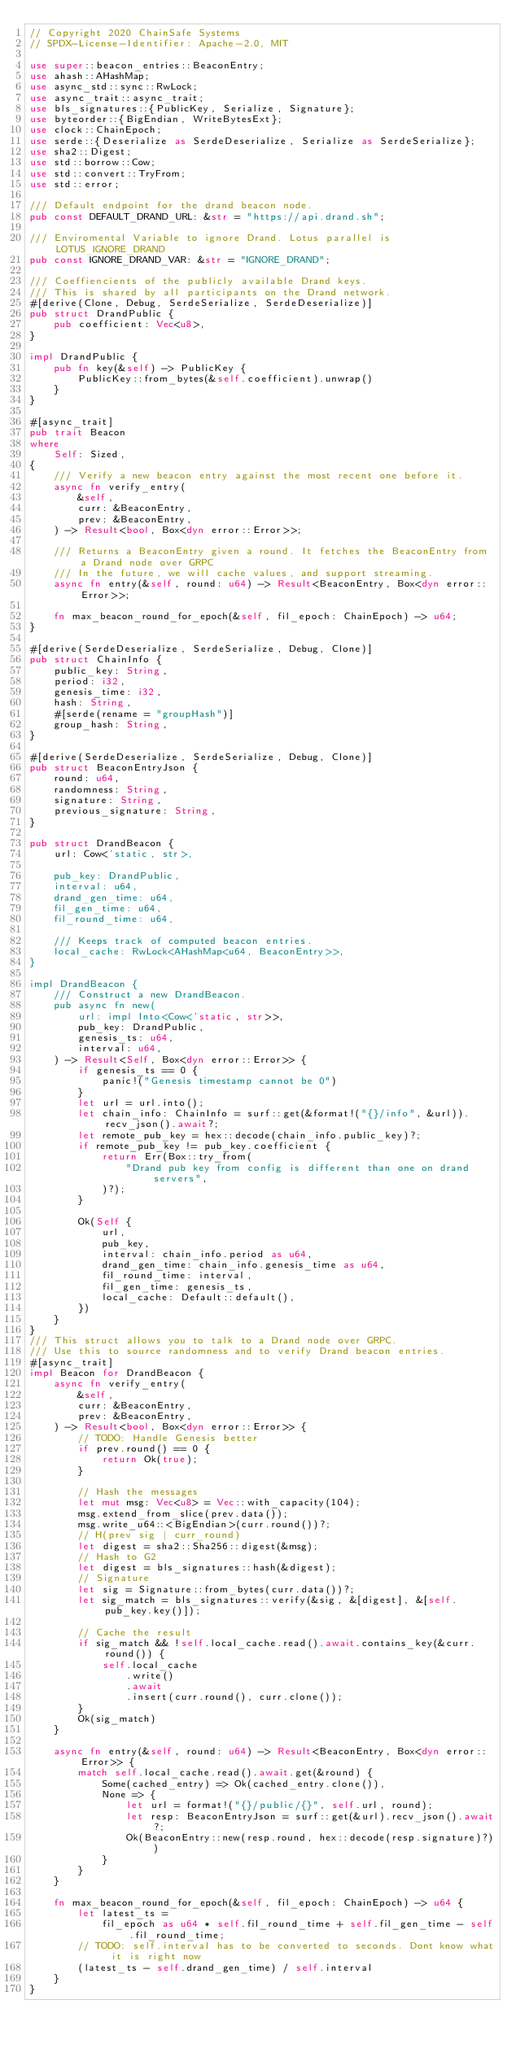<code> <loc_0><loc_0><loc_500><loc_500><_Rust_>// Copyright 2020 ChainSafe Systems
// SPDX-License-Identifier: Apache-2.0, MIT

use super::beacon_entries::BeaconEntry;
use ahash::AHashMap;
use async_std::sync::RwLock;
use async_trait::async_trait;
use bls_signatures::{PublicKey, Serialize, Signature};
use byteorder::{BigEndian, WriteBytesExt};
use clock::ChainEpoch;
use serde::{Deserialize as SerdeDeserialize, Serialize as SerdeSerialize};
use sha2::Digest;
use std::borrow::Cow;
use std::convert::TryFrom;
use std::error;

/// Default endpoint for the drand beacon node.
pub const DEFAULT_DRAND_URL: &str = "https://api.drand.sh";

/// Enviromental Variable to ignore Drand. Lotus parallel is LOTUS_IGNORE_DRAND
pub const IGNORE_DRAND_VAR: &str = "IGNORE_DRAND";

/// Coeffiencients of the publicly available Drand keys.
/// This is shared by all participants on the Drand network.
#[derive(Clone, Debug, SerdeSerialize, SerdeDeserialize)]
pub struct DrandPublic {
    pub coefficient: Vec<u8>,
}

impl DrandPublic {
    pub fn key(&self) -> PublicKey {
        PublicKey::from_bytes(&self.coefficient).unwrap()
    }
}

#[async_trait]
pub trait Beacon
where
    Self: Sized,
{
    /// Verify a new beacon entry against the most recent one before it.
    async fn verify_entry(
        &self,
        curr: &BeaconEntry,
        prev: &BeaconEntry,
    ) -> Result<bool, Box<dyn error::Error>>;

    /// Returns a BeaconEntry given a round. It fetches the BeaconEntry from a Drand node over GRPC
    /// In the future, we will cache values, and support streaming.
    async fn entry(&self, round: u64) -> Result<BeaconEntry, Box<dyn error::Error>>;

    fn max_beacon_round_for_epoch(&self, fil_epoch: ChainEpoch) -> u64;
}

#[derive(SerdeDeserialize, SerdeSerialize, Debug, Clone)]
pub struct ChainInfo {
    public_key: String,
    period: i32,
    genesis_time: i32,
    hash: String,
    #[serde(rename = "groupHash")]
    group_hash: String,
}

#[derive(SerdeDeserialize, SerdeSerialize, Debug, Clone)]
pub struct BeaconEntryJson {
    round: u64,
    randomness: String,
    signature: String,
    previous_signature: String,
}

pub struct DrandBeacon {
    url: Cow<'static, str>,

    pub_key: DrandPublic,
    interval: u64,
    drand_gen_time: u64,
    fil_gen_time: u64,
    fil_round_time: u64,

    /// Keeps track of computed beacon entries.
    local_cache: RwLock<AHashMap<u64, BeaconEntry>>,
}

impl DrandBeacon {
    /// Construct a new DrandBeacon.
    pub async fn new(
        url: impl Into<Cow<'static, str>>,
        pub_key: DrandPublic,
        genesis_ts: u64,
        interval: u64,
    ) -> Result<Self, Box<dyn error::Error>> {
        if genesis_ts == 0 {
            panic!("Genesis timestamp cannot be 0")
        }
        let url = url.into();
        let chain_info: ChainInfo = surf::get(&format!("{}/info", &url)).recv_json().await?;
        let remote_pub_key = hex::decode(chain_info.public_key)?;
        if remote_pub_key != pub_key.coefficient {
            return Err(Box::try_from(
                "Drand pub key from config is different than one on drand servers",
            )?);
        }

        Ok(Self {
            url,
            pub_key,
            interval: chain_info.period as u64,
            drand_gen_time: chain_info.genesis_time as u64,
            fil_round_time: interval,
            fil_gen_time: genesis_ts,
            local_cache: Default::default(),
        })
    }
}
/// This struct allows you to talk to a Drand node over GRPC.
/// Use this to source randomness and to verify Drand beacon entries.
#[async_trait]
impl Beacon for DrandBeacon {
    async fn verify_entry(
        &self,
        curr: &BeaconEntry,
        prev: &BeaconEntry,
    ) -> Result<bool, Box<dyn error::Error>> {
        // TODO: Handle Genesis better
        if prev.round() == 0 {
            return Ok(true);
        }

        // Hash the messages
        let mut msg: Vec<u8> = Vec::with_capacity(104);
        msg.extend_from_slice(prev.data());
        msg.write_u64::<BigEndian>(curr.round())?;
        // H(prev sig | curr_round)
        let digest = sha2::Sha256::digest(&msg);
        // Hash to G2
        let digest = bls_signatures::hash(&digest);
        // Signature
        let sig = Signature::from_bytes(curr.data())?;
        let sig_match = bls_signatures::verify(&sig, &[digest], &[self.pub_key.key()]);

        // Cache the result
        if sig_match && !self.local_cache.read().await.contains_key(&curr.round()) {
            self.local_cache
                .write()
                .await
                .insert(curr.round(), curr.clone());
        }
        Ok(sig_match)
    }

    async fn entry(&self, round: u64) -> Result<BeaconEntry, Box<dyn error::Error>> {
        match self.local_cache.read().await.get(&round) {
            Some(cached_entry) => Ok(cached_entry.clone()),
            None => {
                let url = format!("{}/public/{}", self.url, round);
                let resp: BeaconEntryJson = surf::get(&url).recv_json().await?;
                Ok(BeaconEntry::new(resp.round, hex::decode(resp.signature)?))
            }
        }
    }

    fn max_beacon_round_for_epoch(&self, fil_epoch: ChainEpoch) -> u64 {
        let latest_ts =
            fil_epoch as u64 * self.fil_round_time + self.fil_gen_time - self.fil_round_time;
        // TODO: self.interval has to be converted to seconds. Dont know what it is right now
        (latest_ts - self.drand_gen_time) / self.interval
    }
}
</code> 